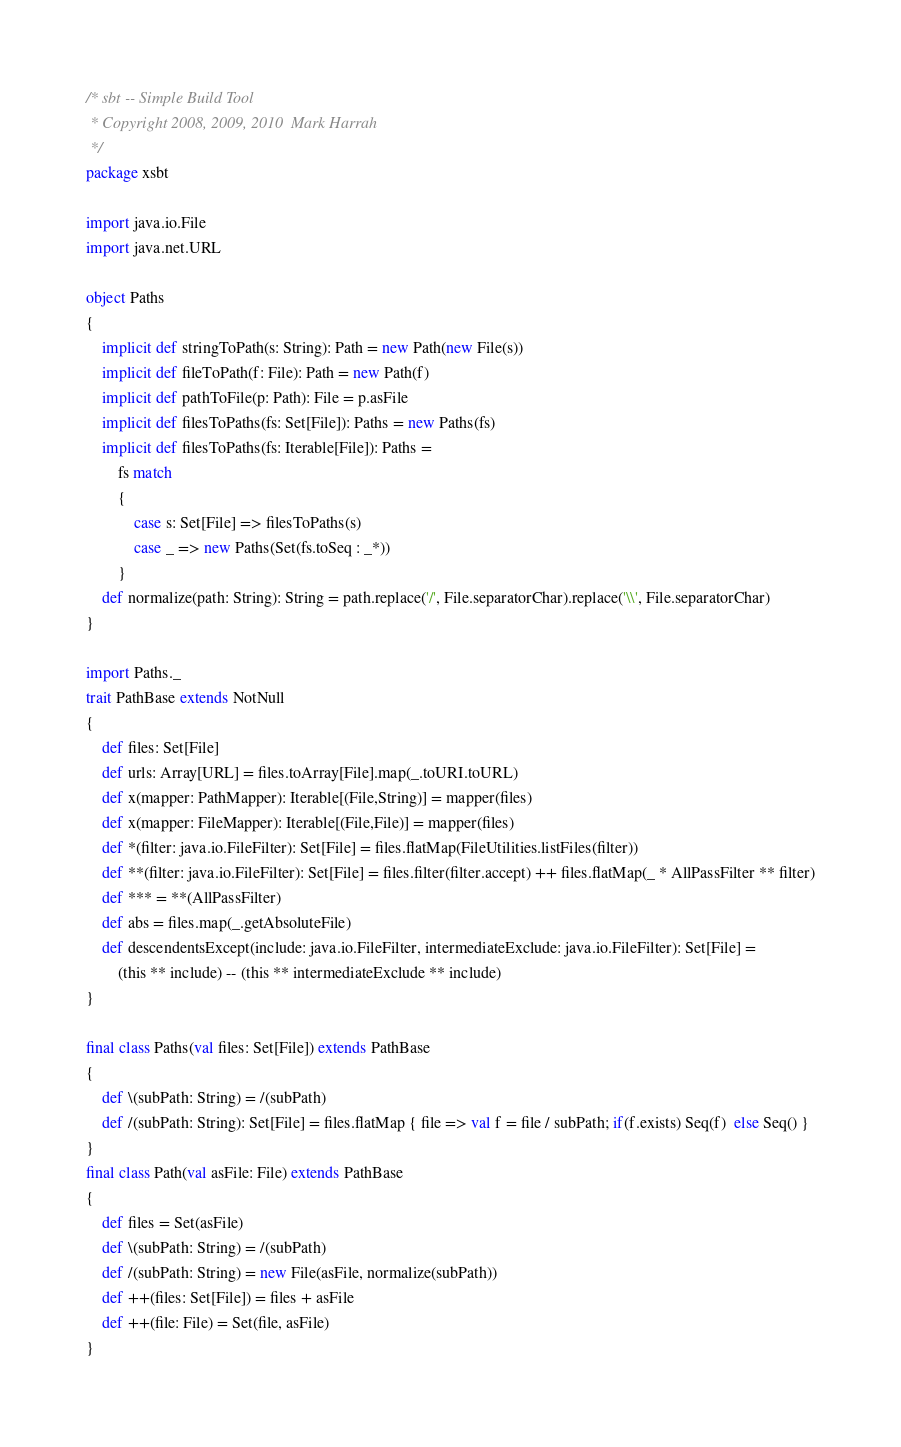<code> <loc_0><loc_0><loc_500><loc_500><_Scala_>/* sbt -- Simple Build Tool
 * Copyright 2008, 2009, 2010  Mark Harrah
 */
package xsbt

import java.io.File
import java.net.URL

object Paths
{
	implicit def stringToPath(s: String): Path = new Path(new File(s))
	implicit def fileToPath(f: File): Path = new Path(f)
	implicit def pathToFile(p: Path): File = p.asFile
	implicit def filesToPaths(fs: Set[File]): Paths = new Paths(fs)
	implicit def filesToPaths(fs: Iterable[File]): Paths =
		fs match
		{
			case s: Set[File] => filesToPaths(s)
			case _ => new Paths(Set(fs.toSeq : _*))
		}
	def normalize(path: String): String = path.replace('/', File.separatorChar).replace('\\', File.separatorChar)
}

import Paths._
trait PathBase extends NotNull
{
	def files: Set[File]
	def urls: Array[URL] = files.toArray[File].map(_.toURI.toURL)
	def x(mapper: PathMapper): Iterable[(File,String)] = mapper(files)
	def x(mapper: FileMapper): Iterable[(File,File)] = mapper(files)
	def *(filter: java.io.FileFilter): Set[File] = files.flatMap(FileUtilities.listFiles(filter))
	def **(filter: java.io.FileFilter): Set[File] = files.filter(filter.accept) ++ files.flatMap(_ * AllPassFilter ** filter)
	def *** = **(AllPassFilter)
	def abs = files.map(_.getAbsoluteFile)
	def descendentsExcept(include: java.io.FileFilter, intermediateExclude: java.io.FileFilter): Set[File] =
		(this ** include) -- (this ** intermediateExclude ** include)
}

final class Paths(val files: Set[File]) extends PathBase
{
	def \(subPath: String) = /(subPath)
	def /(subPath: String): Set[File] = files.flatMap { file => val f = file / subPath; if(f.exists) Seq(f)  else Seq() }
}
final class Path(val asFile: File) extends PathBase
{
	def files = Set(asFile)
	def \(subPath: String) = /(subPath)
	def /(subPath: String) = new File(asFile, normalize(subPath))
	def ++(files: Set[File]) = files + asFile
	def ++(file: File) = Set(file, asFile)
}</code> 